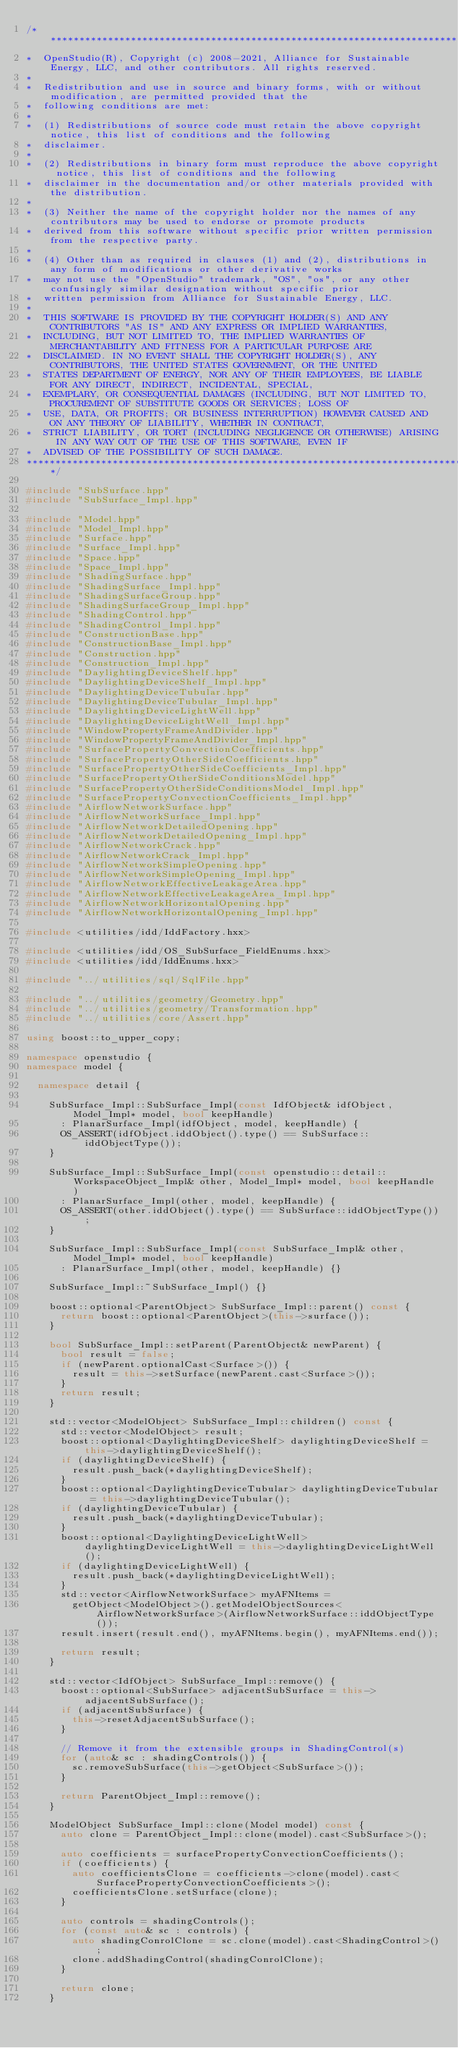<code> <loc_0><loc_0><loc_500><loc_500><_C++_>/***********************************************************************************************************************
*  OpenStudio(R), Copyright (c) 2008-2021, Alliance for Sustainable Energy, LLC, and other contributors. All rights reserved.
*
*  Redistribution and use in source and binary forms, with or without modification, are permitted provided that the
*  following conditions are met:
*
*  (1) Redistributions of source code must retain the above copyright notice, this list of conditions and the following
*  disclaimer.
*
*  (2) Redistributions in binary form must reproduce the above copyright notice, this list of conditions and the following
*  disclaimer in the documentation and/or other materials provided with the distribution.
*
*  (3) Neither the name of the copyright holder nor the names of any contributors may be used to endorse or promote products
*  derived from this software without specific prior written permission from the respective party.
*
*  (4) Other than as required in clauses (1) and (2), distributions in any form of modifications or other derivative works
*  may not use the "OpenStudio" trademark, "OS", "os", or any other confusingly similar designation without specific prior
*  written permission from Alliance for Sustainable Energy, LLC.
*
*  THIS SOFTWARE IS PROVIDED BY THE COPYRIGHT HOLDER(S) AND ANY CONTRIBUTORS "AS IS" AND ANY EXPRESS OR IMPLIED WARRANTIES,
*  INCLUDING, BUT NOT LIMITED TO, THE IMPLIED WARRANTIES OF MERCHANTABILITY AND FITNESS FOR A PARTICULAR PURPOSE ARE
*  DISCLAIMED. IN NO EVENT SHALL THE COPYRIGHT HOLDER(S), ANY CONTRIBUTORS, THE UNITED STATES GOVERNMENT, OR THE UNITED
*  STATES DEPARTMENT OF ENERGY, NOR ANY OF THEIR EMPLOYEES, BE LIABLE FOR ANY DIRECT, INDIRECT, INCIDENTAL, SPECIAL,
*  EXEMPLARY, OR CONSEQUENTIAL DAMAGES (INCLUDING, BUT NOT LIMITED TO, PROCUREMENT OF SUBSTITUTE GOODS OR SERVICES; LOSS OF
*  USE, DATA, OR PROFITS; OR BUSINESS INTERRUPTION) HOWEVER CAUSED AND ON ANY THEORY OF LIABILITY, WHETHER IN CONTRACT,
*  STRICT LIABILITY, OR TORT (INCLUDING NEGLIGENCE OR OTHERWISE) ARISING IN ANY WAY OUT OF THE USE OF THIS SOFTWARE, EVEN IF
*  ADVISED OF THE POSSIBILITY OF SUCH DAMAGE.
***********************************************************************************************************************/

#include "SubSurface.hpp"
#include "SubSurface_Impl.hpp"

#include "Model.hpp"
#include "Model_Impl.hpp"
#include "Surface.hpp"
#include "Surface_Impl.hpp"
#include "Space.hpp"
#include "Space_Impl.hpp"
#include "ShadingSurface.hpp"
#include "ShadingSurface_Impl.hpp"
#include "ShadingSurfaceGroup.hpp"
#include "ShadingSurfaceGroup_Impl.hpp"
#include "ShadingControl.hpp"
#include "ShadingControl_Impl.hpp"
#include "ConstructionBase.hpp"
#include "ConstructionBase_Impl.hpp"
#include "Construction.hpp"
#include "Construction_Impl.hpp"
#include "DaylightingDeviceShelf.hpp"
#include "DaylightingDeviceShelf_Impl.hpp"
#include "DaylightingDeviceTubular.hpp"
#include "DaylightingDeviceTubular_Impl.hpp"
#include "DaylightingDeviceLightWell.hpp"
#include "DaylightingDeviceLightWell_Impl.hpp"
#include "WindowPropertyFrameAndDivider.hpp"
#include "WindowPropertyFrameAndDivider_Impl.hpp"
#include "SurfacePropertyConvectionCoefficients.hpp"
#include "SurfacePropertyOtherSideCoefficients.hpp"
#include "SurfacePropertyOtherSideCoefficients_Impl.hpp"
#include "SurfacePropertyOtherSideConditionsModel.hpp"
#include "SurfacePropertyOtherSideConditionsModel_Impl.hpp"
#include "SurfacePropertyConvectionCoefficients_Impl.hpp"
#include "AirflowNetworkSurface.hpp"
#include "AirflowNetworkSurface_Impl.hpp"
#include "AirflowNetworkDetailedOpening.hpp"
#include "AirflowNetworkDetailedOpening_Impl.hpp"
#include "AirflowNetworkCrack.hpp"
#include "AirflowNetworkCrack_Impl.hpp"
#include "AirflowNetworkSimpleOpening.hpp"
#include "AirflowNetworkSimpleOpening_Impl.hpp"
#include "AirflowNetworkEffectiveLeakageArea.hpp"
#include "AirflowNetworkEffectiveLeakageArea_Impl.hpp"
#include "AirflowNetworkHorizontalOpening.hpp"
#include "AirflowNetworkHorizontalOpening_Impl.hpp"

#include <utilities/idd/IddFactory.hxx>

#include <utilities/idd/OS_SubSurface_FieldEnums.hxx>
#include <utilities/idd/IddEnums.hxx>

#include "../utilities/sql/SqlFile.hpp"

#include "../utilities/geometry/Geometry.hpp"
#include "../utilities/geometry/Transformation.hpp"
#include "../utilities/core/Assert.hpp"

using boost::to_upper_copy;

namespace openstudio {
namespace model {

  namespace detail {

    SubSurface_Impl::SubSurface_Impl(const IdfObject& idfObject, Model_Impl* model, bool keepHandle)
      : PlanarSurface_Impl(idfObject, model, keepHandle) {
      OS_ASSERT(idfObject.iddObject().type() == SubSurface::iddObjectType());
    }

    SubSurface_Impl::SubSurface_Impl(const openstudio::detail::WorkspaceObject_Impl& other, Model_Impl* model, bool keepHandle)
      : PlanarSurface_Impl(other, model, keepHandle) {
      OS_ASSERT(other.iddObject().type() == SubSurface::iddObjectType());
    }

    SubSurface_Impl::SubSurface_Impl(const SubSurface_Impl& other, Model_Impl* model, bool keepHandle)
      : PlanarSurface_Impl(other, model, keepHandle) {}

    SubSurface_Impl::~SubSurface_Impl() {}

    boost::optional<ParentObject> SubSurface_Impl::parent() const {
      return boost::optional<ParentObject>(this->surface());
    }

    bool SubSurface_Impl::setParent(ParentObject& newParent) {
      bool result = false;
      if (newParent.optionalCast<Surface>()) {
        result = this->setSurface(newParent.cast<Surface>());
      }
      return result;
    }

    std::vector<ModelObject> SubSurface_Impl::children() const {
      std::vector<ModelObject> result;
      boost::optional<DaylightingDeviceShelf> daylightingDeviceShelf = this->daylightingDeviceShelf();
      if (daylightingDeviceShelf) {
        result.push_back(*daylightingDeviceShelf);
      }
      boost::optional<DaylightingDeviceTubular> daylightingDeviceTubular = this->daylightingDeviceTubular();
      if (daylightingDeviceTubular) {
        result.push_back(*daylightingDeviceTubular);
      }
      boost::optional<DaylightingDeviceLightWell> daylightingDeviceLightWell = this->daylightingDeviceLightWell();
      if (daylightingDeviceLightWell) {
        result.push_back(*daylightingDeviceLightWell);
      }
      std::vector<AirflowNetworkSurface> myAFNItems =
        getObject<ModelObject>().getModelObjectSources<AirflowNetworkSurface>(AirflowNetworkSurface::iddObjectType());
      result.insert(result.end(), myAFNItems.begin(), myAFNItems.end());

      return result;
    }

    std::vector<IdfObject> SubSurface_Impl::remove() {
      boost::optional<SubSurface> adjacentSubSurface = this->adjacentSubSurface();
      if (adjacentSubSurface) {
        this->resetAdjacentSubSurface();
      }

      // Remove it from the extensible groups in ShadingControl(s)
      for (auto& sc : shadingControls()) {
        sc.removeSubSurface(this->getObject<SubSurface>());
      }

      return ParentObject_Impl::remove();
    }

    ModelObject SubSurface_Impl::clone(Model model) const {
      auto clone = ParentObject_Impl::clone(model).cast<SubSurface>();

      auto coefficients = surfacePropertyConvectionCoefficients();
      if (coefficients) {
        auto coefficientsClone = coefficients->clone(model).cast<SurfacePropertyConvectionCoefficients>();
        coefficientsClone.setSurface(clone);
      }

      auto controls = shadingControls();
      for (const auto& sc : controls) {
        auto shadingConrolClone = sc.clone(model).cast<ShadingControl>();
        clone.addShadingControl(shadingConrolClone);
      }

      return clone;
    }
</code> 